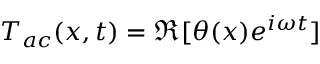<formula> <loc_0><loc_0><loc_500><loc_500>T _ { a c } ( x , t ) = \Re [ \theta ( x ) e ^ { i \omega t } ]</formula> 